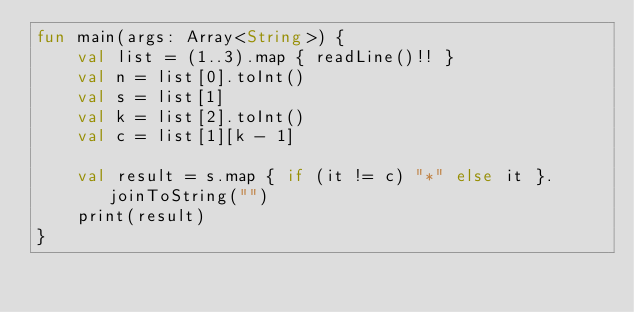<code> <loc_0><loc_0><loc_500><loc_500><_Kotlin_>fun main(args: Array<String>) {
    val list = (1..3).map { readLine()!! }
    val n = list[0].toInt()
    val s = list[1]
    val k = list[2].toInt()
    val c = list[1][k - 1]

    val result = s.map { if (it != c) "*" else it }.joinToString("")
    print(result)
}</code> 